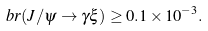<formula> <loc_0><loc_0><loc_500><loc_500>b r ( J / \psi \rightarrow \gamma \xi ) \geq 0 . 1 \times 1 0 ^ { - 3 } .</formula> 